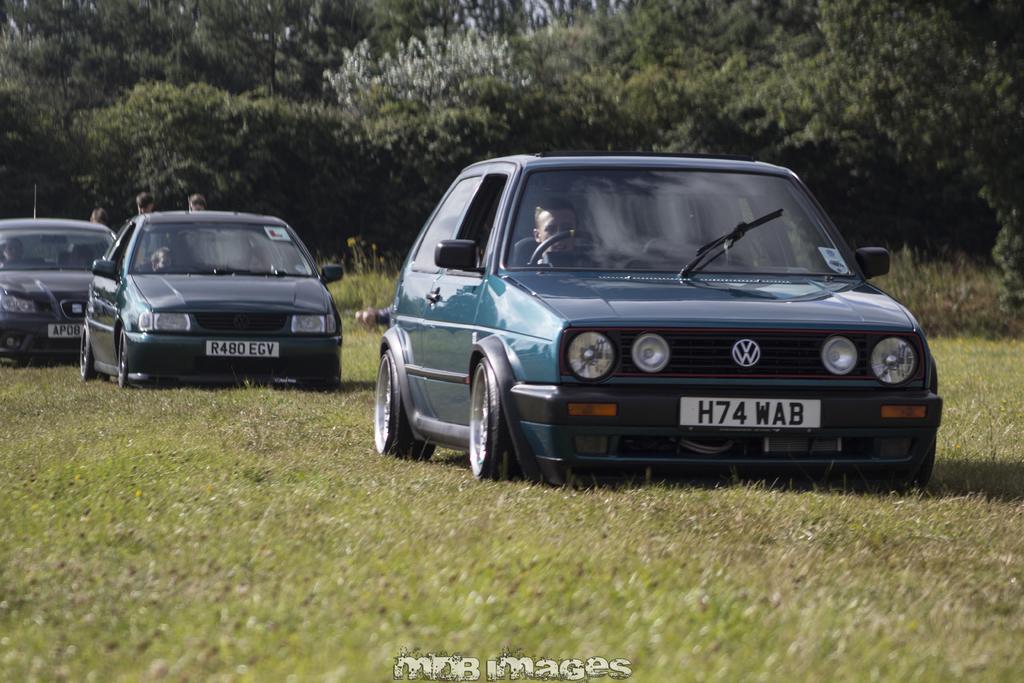In one or two sentences, can you explain what this image depicts? In this image I can see cars visible on ground , in the car I can see persons and I can see three persons visible back side of the car on the left side ,at the top I can see trees ,at the bottom I can see text. 